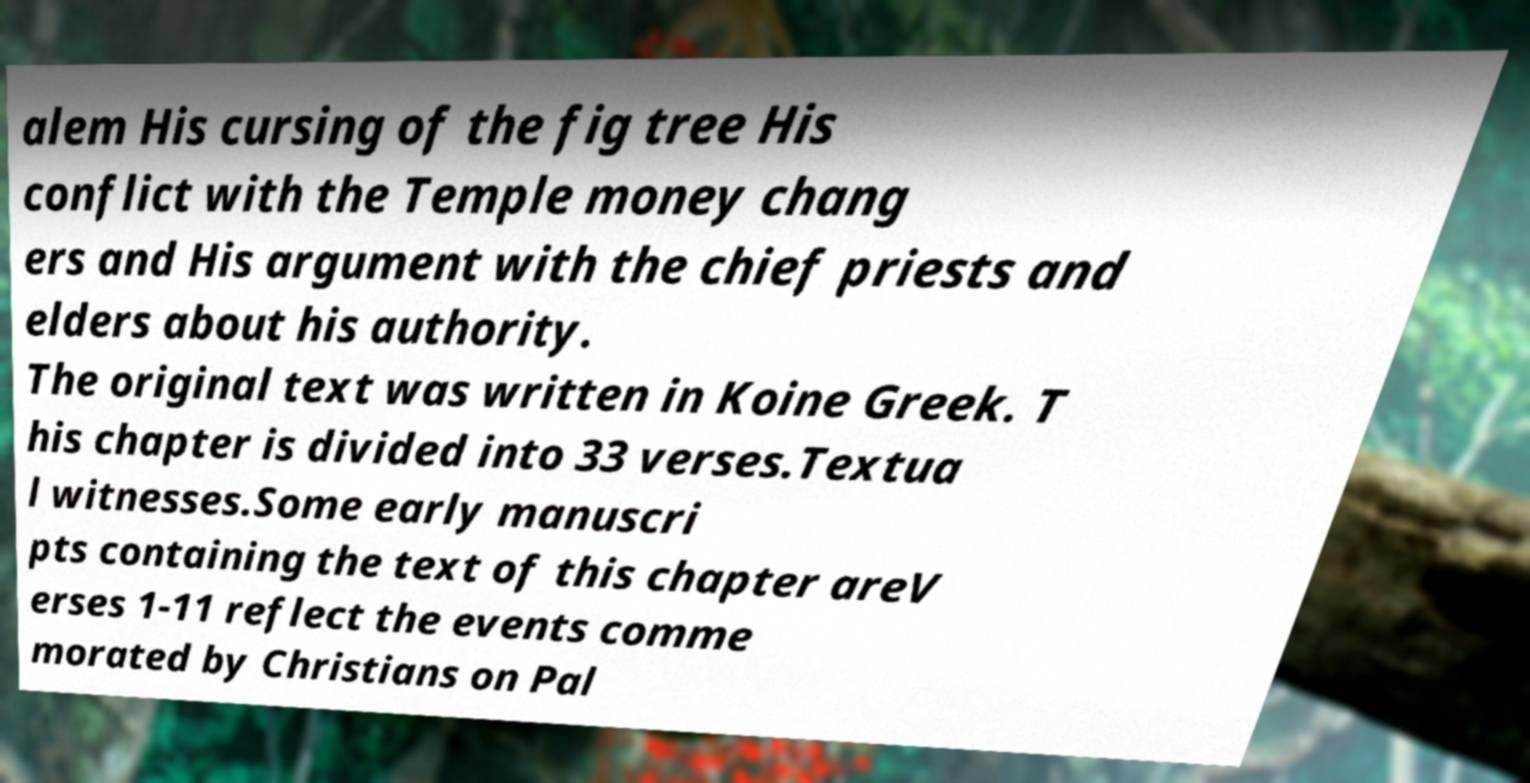Please identify and transcribe the text found in this image. alem His cursing of the fig tree His conflict with the Temple money chang ers and His argument with the chief priests and elders about his authority. The original text was written in Koine Greek. T his chapter is divided into 33 verses.Textua l witnesses.Some early manuscri pts containing the text of this chapter areV erses 1-11 reflect the events comme morated by Christians on Pal 